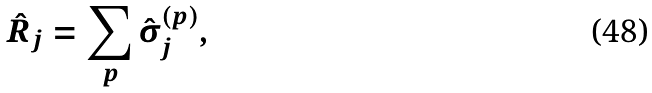Convert formula to latex. <formula><loc_0><loc_0><loc_500><loc_500>\hat { R } _ { j } = \sum _ { p } \hat { \sigma } _ { j } ^ { ( p ) } ,</formula> 